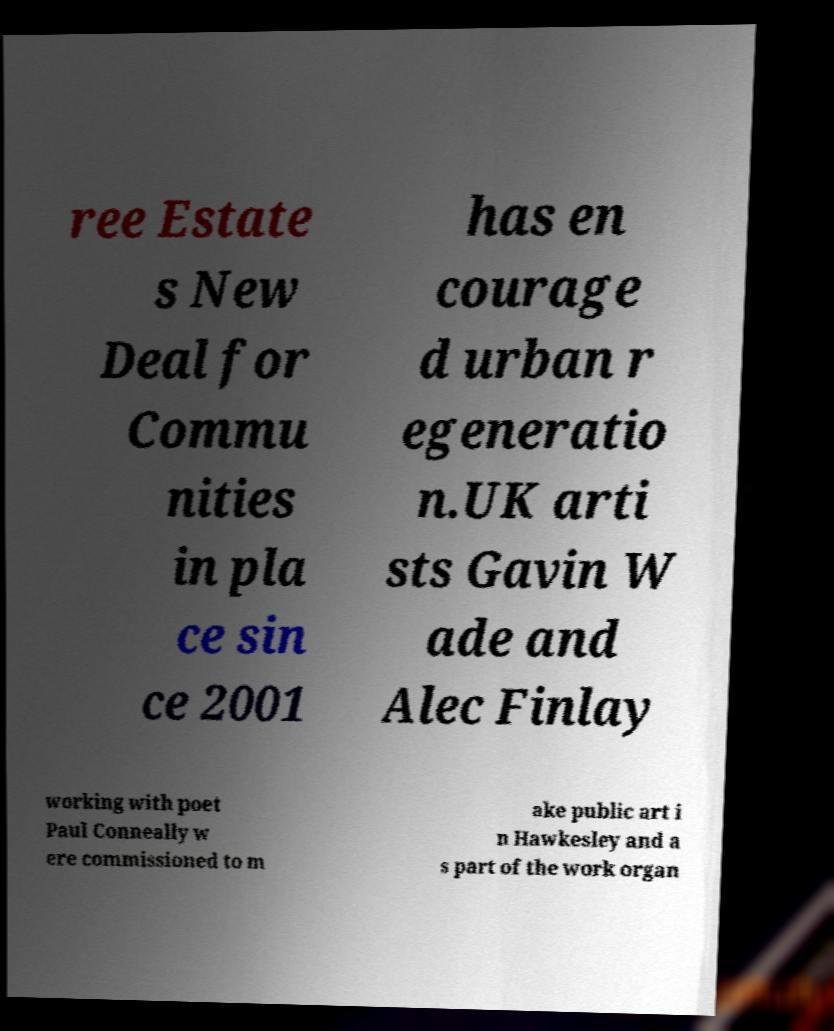I need the written content from this picture converted into text. Can you do that? ree Estate s New Deal for Commu nities in pla ce sin ce 2001 has en courage d urban r egeneratio n.UK arti sts Gavin W ade and Alec Finlay working with poet Paul Conneally w ere commissioned to m ake public art i n Hawkesley and a s part of the work organ 